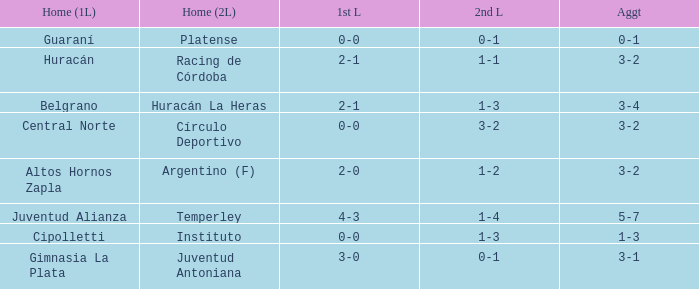Which team participated in the second leg at their home ground, having a 0-1 score, and drew 0-0 in the first leg? Platense. 